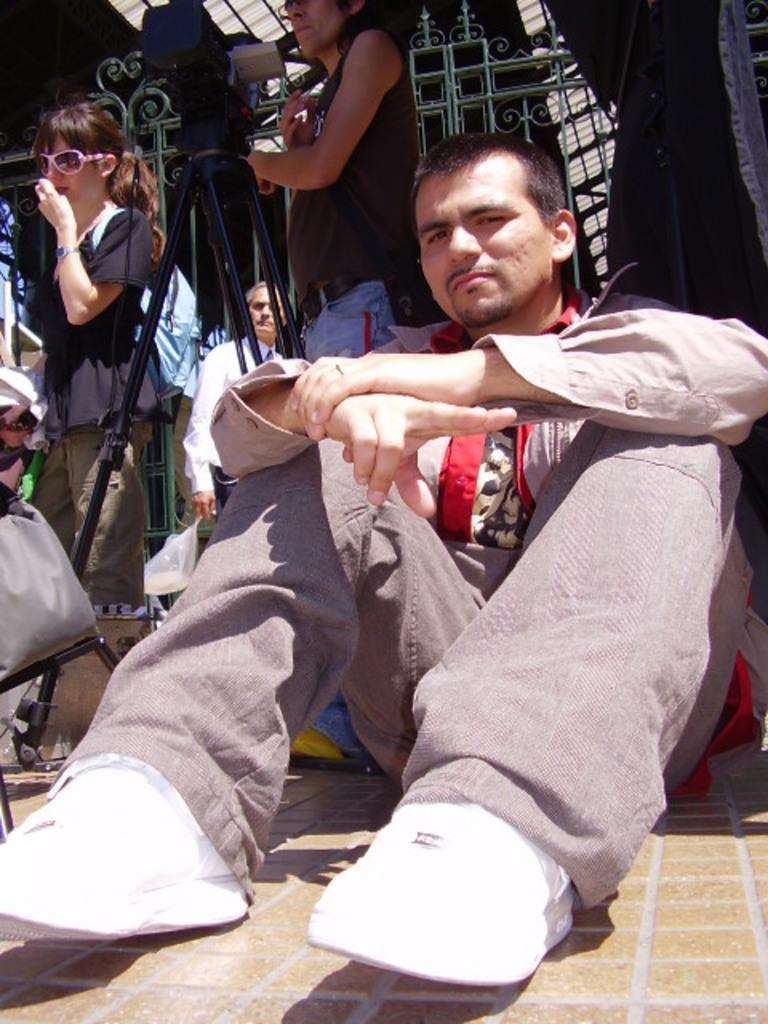What is the main subject in the middle of the image? There is a man sitting in the middle of the image. What are the people behind the man doing? The people are standing behind the man. What can be seen in the background of the image? There is a fencing in the image. Who is the creator of the fencing in the image? There is no information about the creator of the fencing in the image. 